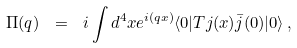<formula> <loc_0><loc_0><loc_500><loc_500>\Pi ( q ) \ = \ i \int d ^ { 4 } x e ^ { i ( q x ) } \langle 0 | T j ( x ) \bar { j } ( 0 ) | 0 \rangle \, ,</formula> 